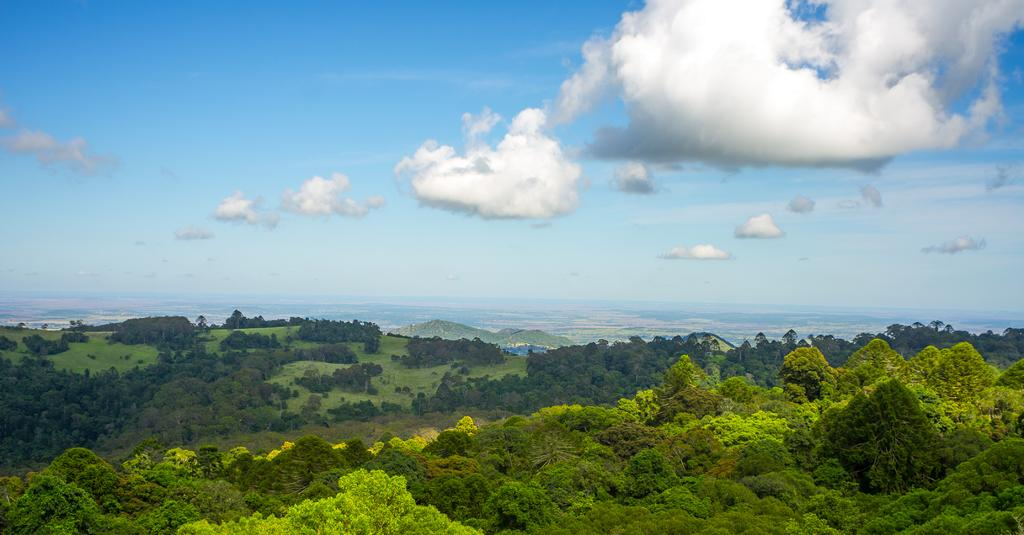What can be seen in the sky in the image? Clouds are visible in the sky. What type of vegetation is present in the image? There are trees in the image. What type of grape is hanging from the tree in the image? There are no grapes present in the image; only clouds and trees can be seen. Can you hear the sound of thunder in the image? There is no sound present in the image, so it is not possible to determine if thunder can be heard. 